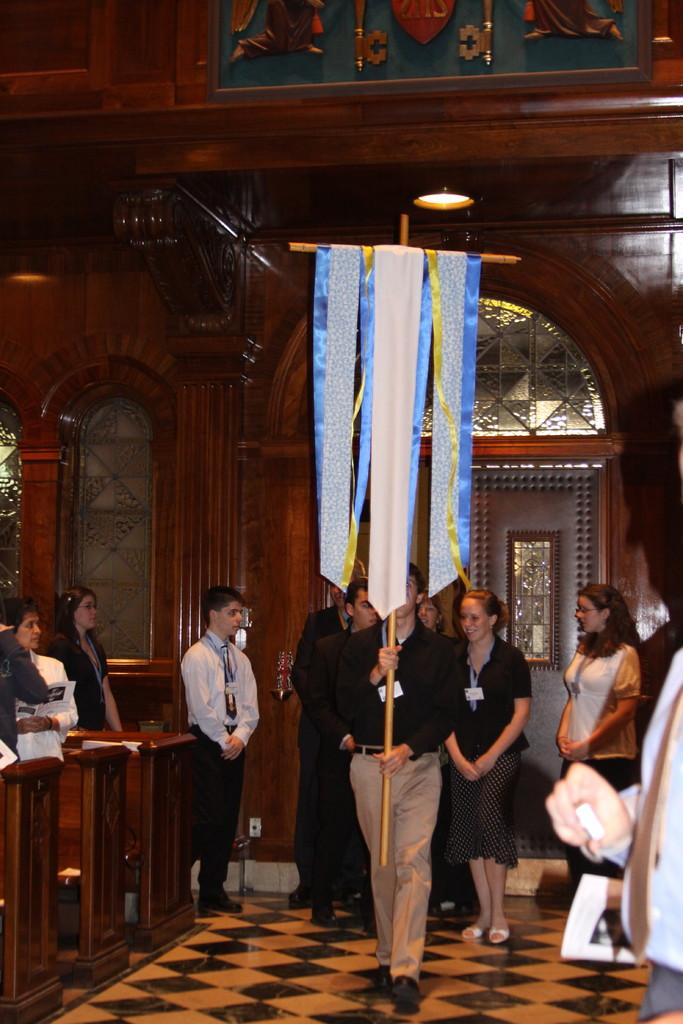What are the people in the image doing? The people in the image are walking. What are the people holding while walking? The people are holding a cross. Where are the persons standing in relation to the benches? The persons are standing at the left side of the benches. What type of cap can be seen on the person standing at the right side of the benches? There is no person standing at the right side of the benches in the image. 